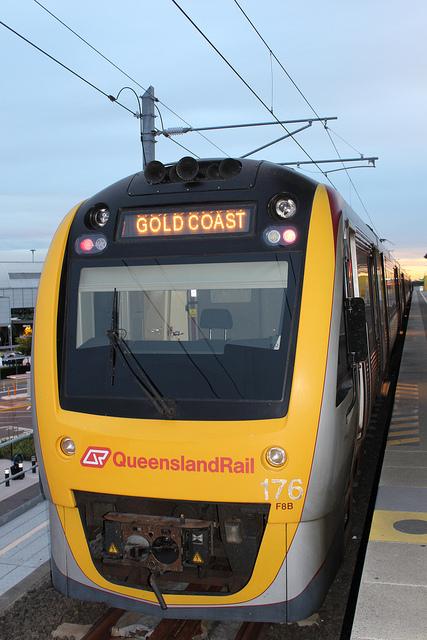What country is this train located in?
Short answer required. Australia. What is the color of the train?
Concise answer only. Yellow. What is the train used for?
Concise answer only. Transportation. 